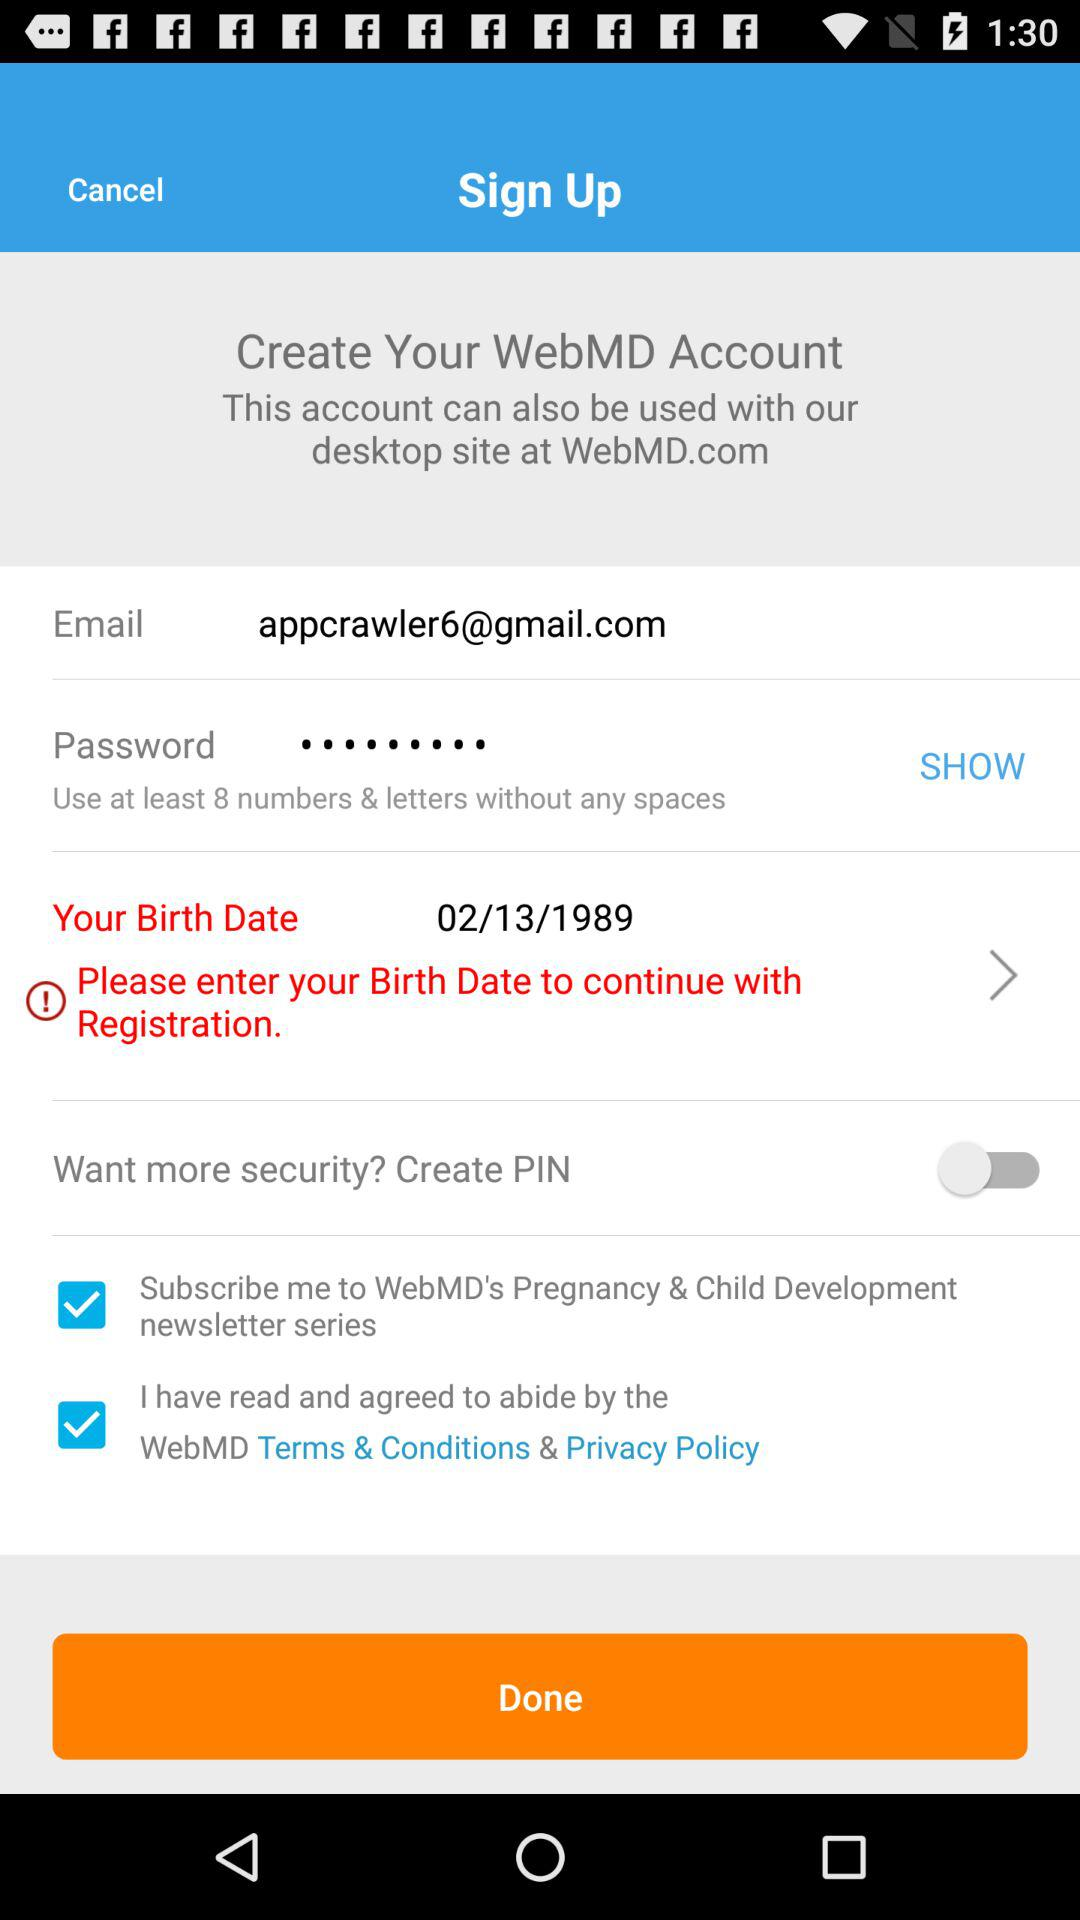What is the long form of PIN?
When the provided information is insufficient, respond with <no answer>. <no answer> 